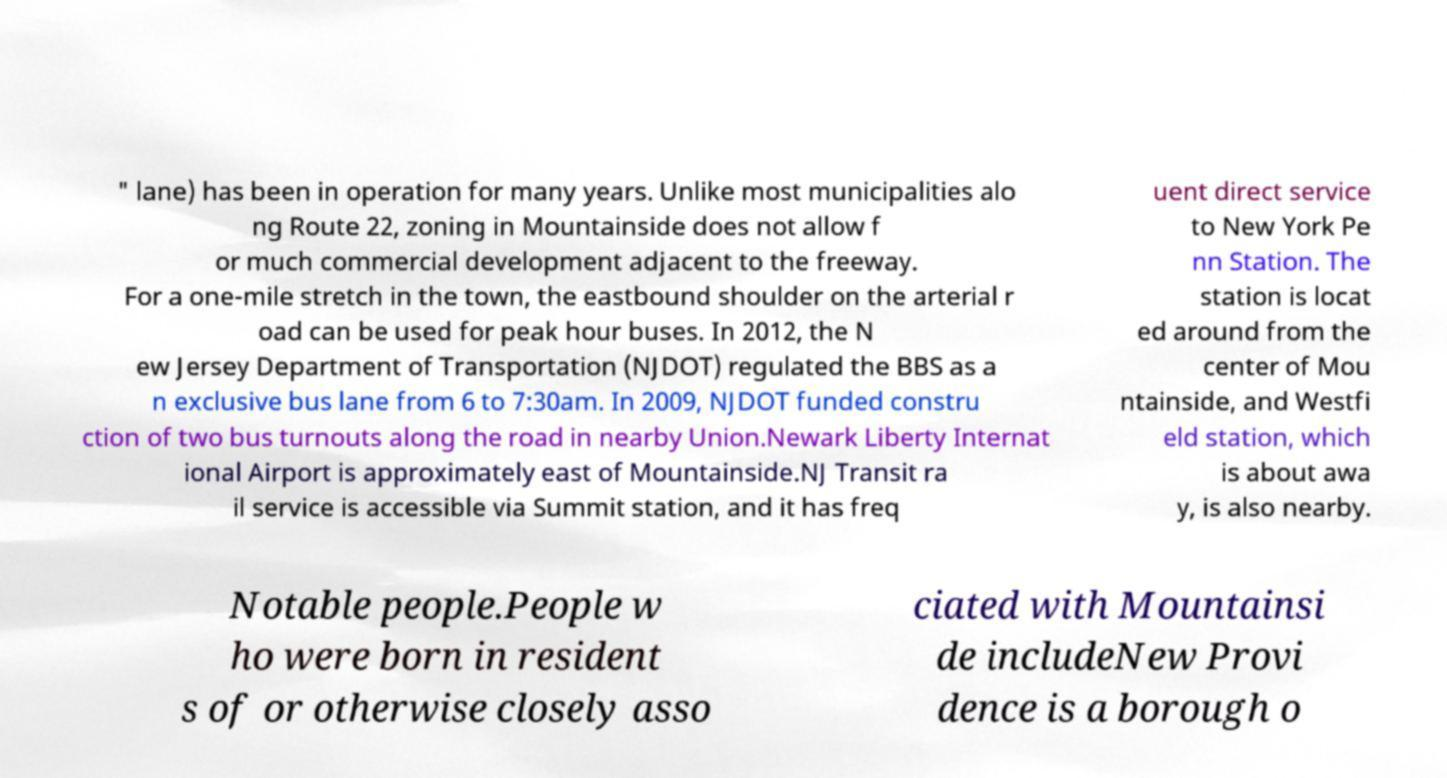Can you read and provide the text displayed in the image?This photo seems to have some interesting text. Can you extract and type it out for me? " lane) has been in operation for many years. Unlike most municipalities alo ng Route 22, zoning in Mountainside does not allow f or much commercial development adjacent to the freeway. For a one-mile stretch in the town, the eastbound shoulder on the arterial r oad can be used for peak hour buses. In 2012, the N ew Jersey Department of Transportation (NJDOT) regulated the BBS as a n exclusive bus lane from 6 to 7:30am. In 2009, NJDOT funded constru ction of two bus turnouts along the road in nearby Union.Newark Liberty Internat ional Airport is approximately east of Mountainside.NJ Transit ra il service is accessible via Summit station, and it has freq uent direct service to New York Pe nn Station. The station is locat ed around from the center of Mou ntainside, and Westfi eld station, which is about awa y, is also nearby. Notable people.People w ho were born in resident s of or otherwise closely asso ciated with Mountainsi de includeNew Provi dence is a borough o 